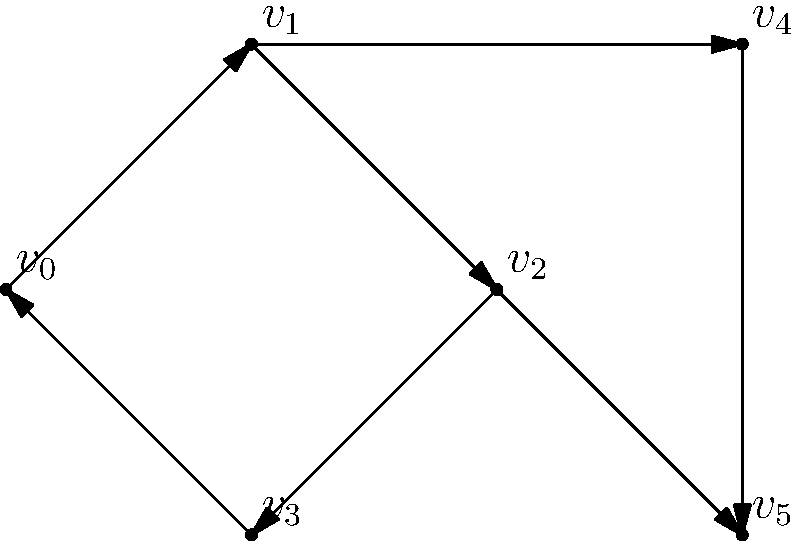In your open-world game, you're implementing a quest dependency system using a directed graph. Each vertex represents a quest, and each edge represents a dependency. You need to detect cycles to prevent impossible quest chains. Given the graph above, how many distinct cycles are present? To detect cycles in a directed graph, we'll use a depth-first search (DFS) approach. Let's go through the process step-by-step:

1) Start from each vertex and perform a DFS.
2) During DFS, keep track of vertices in the current path.
3) If we encounter a vertex that's already in the current path, we've found a cycle.

Let's apply this to our graph:

1) Starting from $v_0$:
   $v_0 \rightarrow v_1 \rightarrow v_2 \rightarrow v_3 \rightarrow v_0$ (Cycle 1)
   $v_0 \rightarrow v_1 \rightarrow v_4 \rightarrow v_5$ (No cycle)

2) Starting from $v_1$:
   $v_1 \rightarrow v_2 \rightarrow v_3 \rightarrow v_0 \rightarrow v_1$ (Same as Cycle 1)
   $v_1 \rightarrow v_4 \rightarrow v_5$ (No cycle)

3) Starting from $v_2$:
   $v_2 \rightarrow v_3 \rightarrow v_0 \rightarrow v_1 \rightarrow v_2$ (Same as Cycle 1)
   $v_2 \rightarrow v_5$ (No cycle)

4) Starting from $v_3$, $v_4$, and $v_5$:
   No new cycles discovered

Therefore, there is only one distinct cycle in this graph: $v_0 \rightarrow v_1 \rightarrow v_2 \rightarrow v_3 \rightarrow v_0$.
Answer: 1 